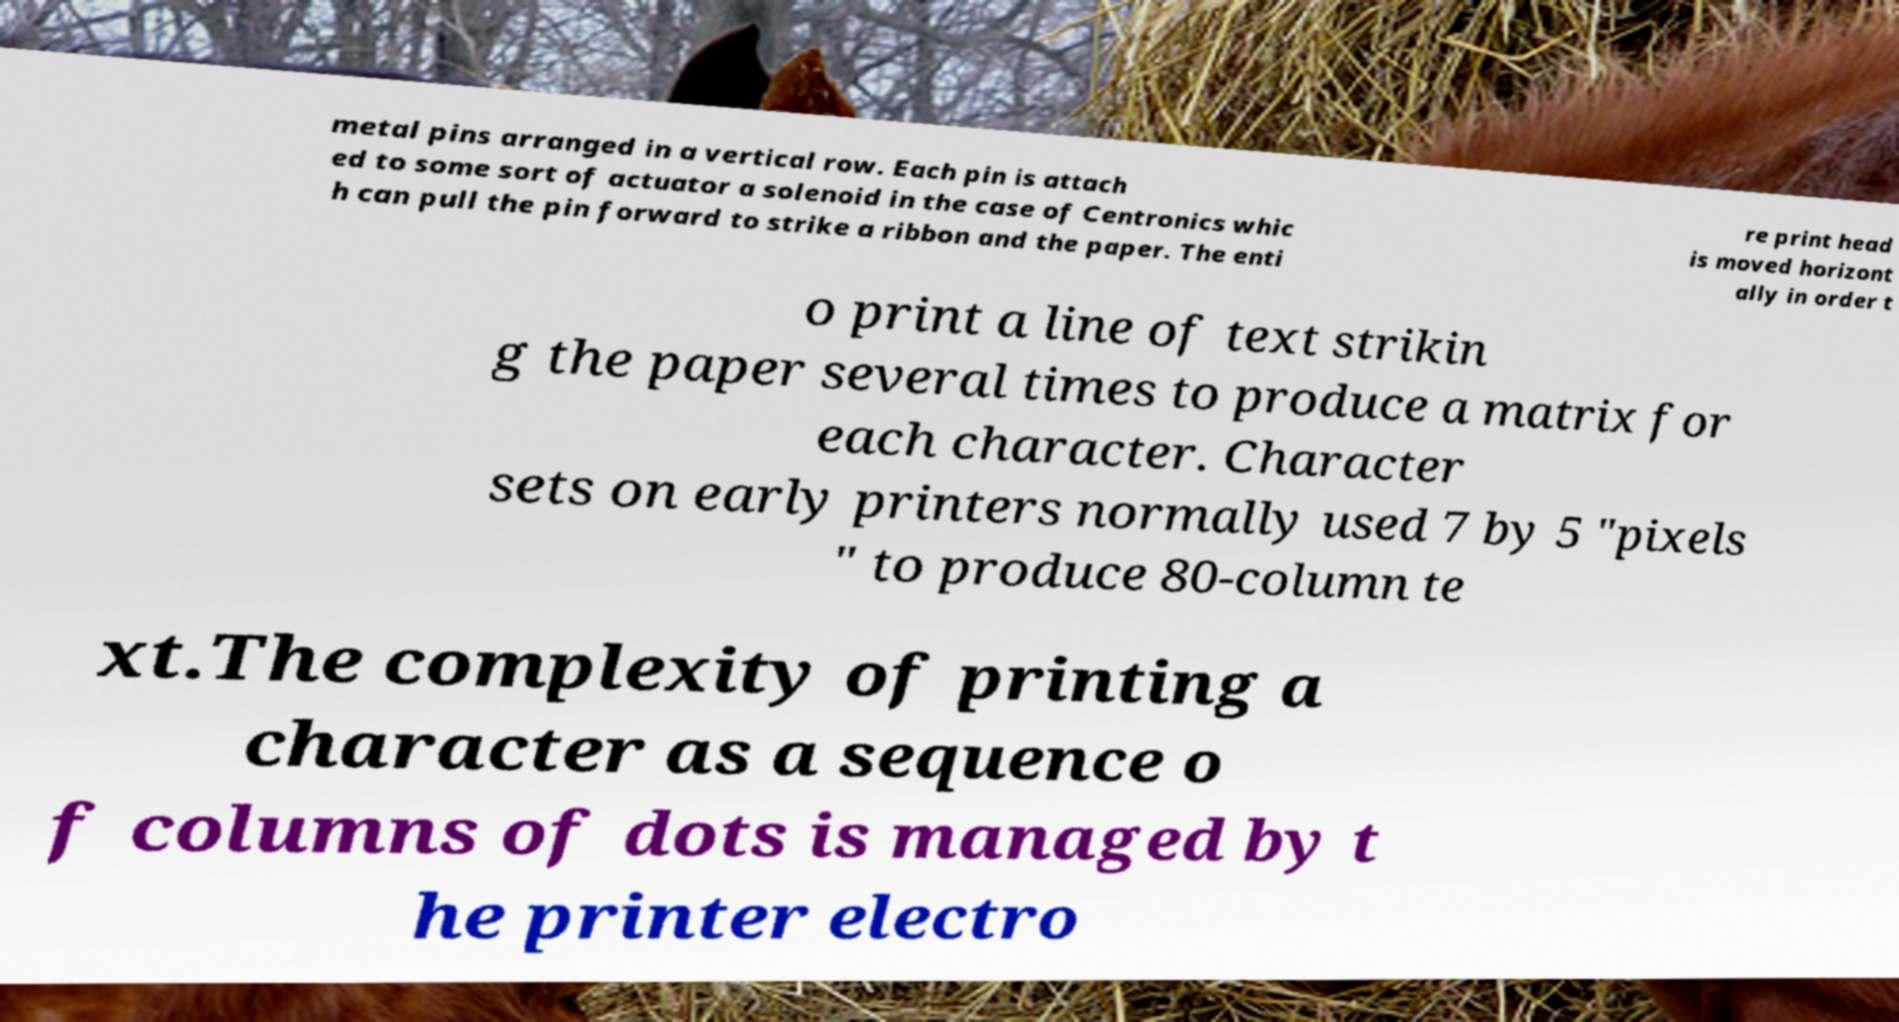There's text embedded in this image that I need extracted. Can you transcribe it verbatim? metal pins arranged in a vertical row. Each pin is attach ed to some sort of actuator a solenoid in the case of Centronics whic h can pull the pin forward to strike a ribbon and the paper. The enti re print head is moved horizont ally in order t o print a line of text strikin g the paper several times to produce a matrix for each character. Character sets on early printers normally used 7 by 5 "pixels " to produce 80-column te xt.The complexity of printing a character as a sequence o f columns of dots is managed by t he printer electro 